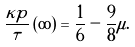Convert formula to latex. <formula><loc_0><loc_0><loc_500><loc_500>\frac { \kappa p } \tau \left ( \infty \right ) = \frac { 1 } { 6 } - \frac { 9 } { 8 } \mu .</formula> 